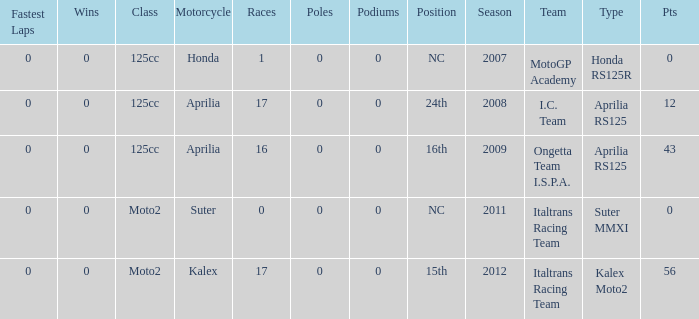What's the number of poles in the season where the team had a Kalex motorcycle? 0.0. 